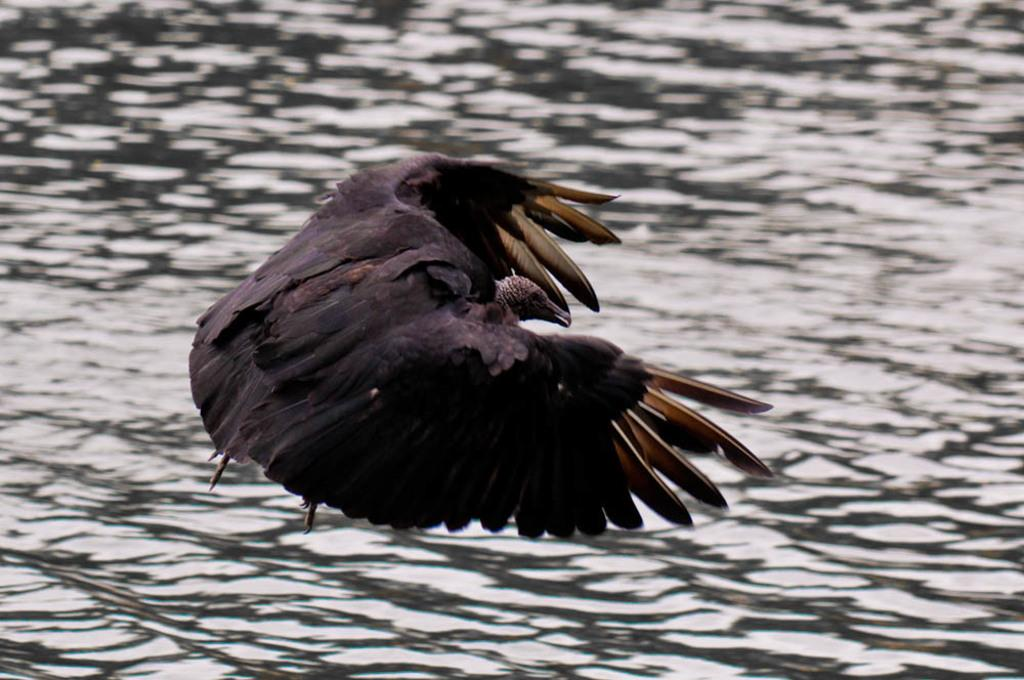What type of animal can be seen in the image? There is a bird in the image. What is visible in the image besides the bird? There is water visible in the image. Where is the sink located in the image? There is no sink present in the image. Can you see any arguments happening in the image? There is no indication of an argument in the image. Is there any money visible in the image? There is no money visible in the image. 